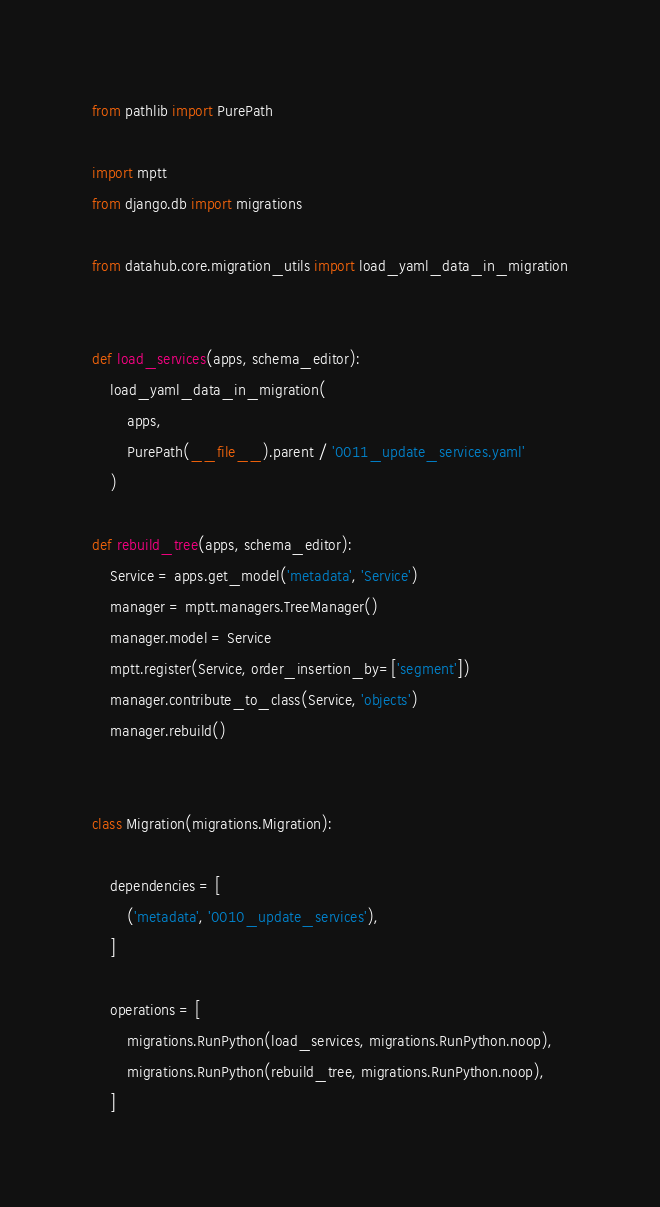Convert code to text. <code><loc_0><loc_0><loc_500><loc_500><_Python_>from pathlib import PurePath

import mptt
from django.db import migrations

from datahub.core.migration_utils import load_yaml_data_in_migration


def load_services(apps, schema_editor):
    load_yaml_data_in_migration(
        apps,
        PurePath(__file__).parent / '0011_update_services.yaml'
    )

def rebuild_tree(apps, schema_editor):
    Service = apps.get_model('metadata', 'Service')
    manager = mptt.managers.TreeManager()
    manager.model = Service
    mptt.register(Service, order_insertion_by=['segment'])
    manager.contribute_to_class(Service, 'objects')
    manager.rebuild()


class Migration(migrations.Migration):

    dependencies = [
        ('metadata', '0010_update_services'),
    ]

    operations = [
        migrations.RunPython(load_services, migrations.RunPython.noop),
        migrations.RunPython(rebuild_tree, migrations.RunPython.noop),
    ]
</code> 